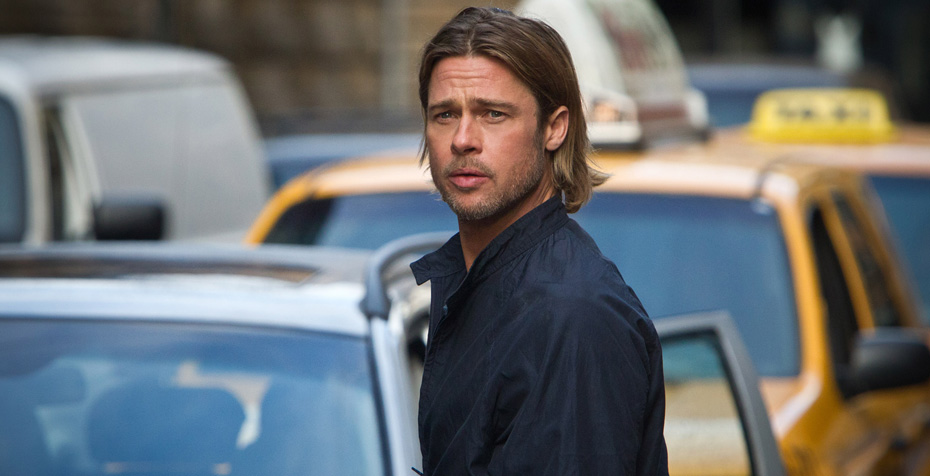Imagine a thrilling chase scene starting from this moment. What happens next? As Jack continues down the street, he suddenly hears urgent shouts behind him. He glances back to see two shadowy figures sprinting in his direction. Without hesitation, he breaks into a run, weaving through the crowded sidewalk and darting past parked cars. The sound of footsteps and excited murmurs of bystanders fill the air, creating a sense of urgency. Jack dashes into a narrow alley, hoping to lose his pursuers, each step driven by a burst of adrenaline. This unexpected chase unveils a hidden subplot of secrets and danger, revealing that Jack's move to the city brought more than just career opportunities—it also brought unforeseen peril. 